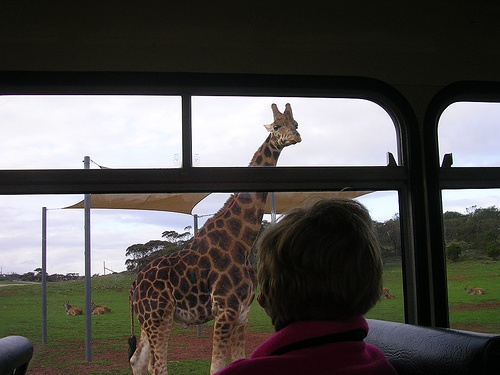Describe the objects in this image and their specific colors. I can see people in black, maroon, darkgreen, and gray tones and giraffe in black, maroon, and gray tones in this image. 